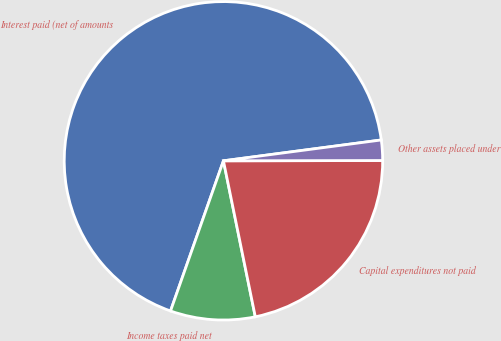<chart> <loc_0><loc_0><loc_500><loc_500><pie_chart><fcel>Interest paid (net of amounts<fcel>Income taxes paid net<fcel>Capital expenditures not paid<fcel>Other assets placed under<nl><fcel>67.52%<fcel>8.6%<fcel>21.82%<fcel>2.06%<nl></chart> 